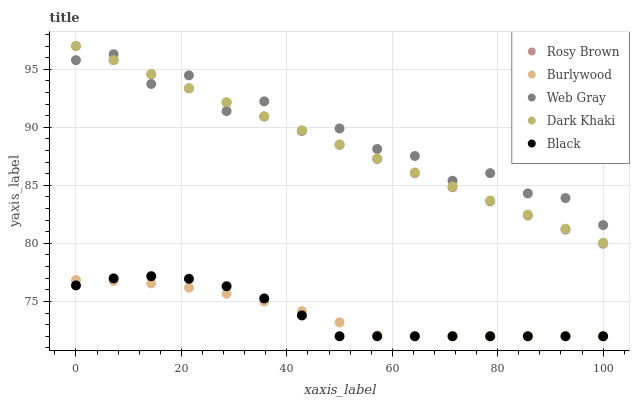Does Burlywood have the minimum area under the curve?
Answer yes or no. Yes. Does Web Gray have the maximum area under the curve?
Answer yes or no. Yes. Does Dark Khaki have the minimum area under the curve?
Answer yes or no. No. Does Dark Khaki have the maximum area under the curve?
Answer yes or no. No. Is Rosy Brown the smoothest?
Answer yes or no. Yes. Is Web Gray the roughest?
Answer yes or no. Yes. Is Dark Khaki the smoothest?
Answer yes or no. No. Is Dark Khaki the roughest?
Answer yes or no. No. Does Burlywood have the lowest value?
Answer yes or no. Yes. Does Dark Khaki have the lowest value?
Answer yes or no. No. Does Rosy Brown have the highest value?
Answer yes or no. Yes. Does Web Gray have the highest value?
Answer yes or no. No. Is Burlywood less than Dark Khaki?
Answer yes or no. Yes. Is Dark Khaki greater than Black?
Answer yes or no. Yes. Does Black intersect Burlywood?
Answer yes or no. Yes. Is Black less than Burlywood?
Answer yes or no. No. Is Black greater than Burlywood?
Answer yes or no. No. Does Burlywood intersect Dark Khaki?
Answer yes or no. No. 